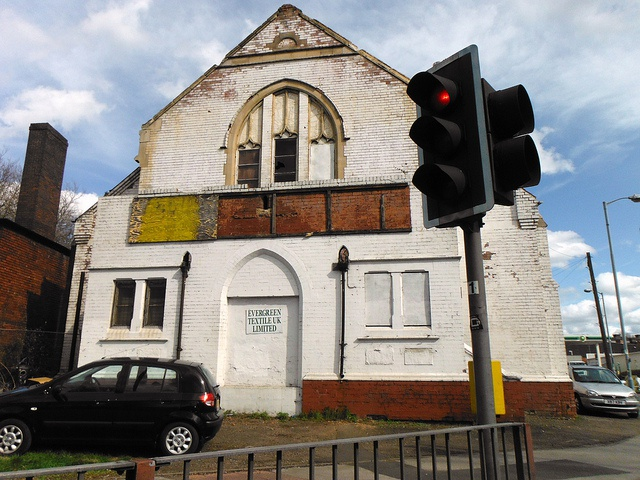Describe the objects in this image and their specific colors. I can see car in lavender, black, gray, darkgray, and lightgray tones, traffic light in lavender, black, gray, lightgray, and darkgray tones, traffic light in lavender, black, gray, and lightblue tones, and car in lavender, black, darkgray, gray, and purple tones in this image. 